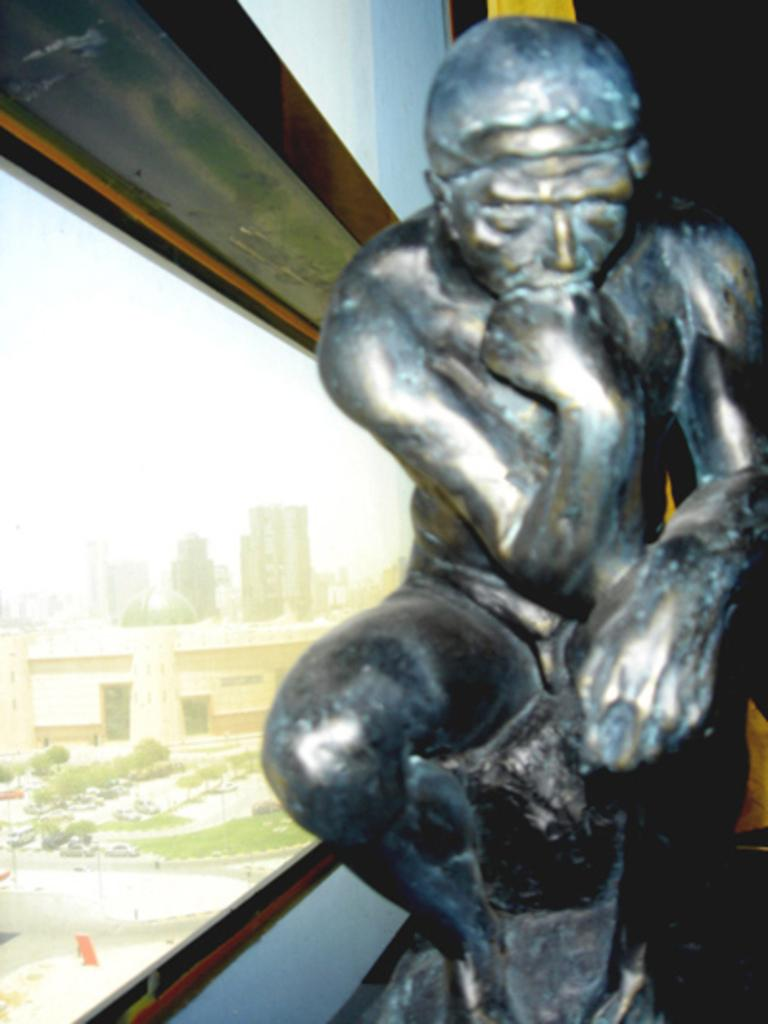Where might the image have been taken? The image might be taken inside a room. What can be seen on the right side of the image? There is a sculpture on the right side of the image. What type of window is present in the image? There is a glass window in the image. What can be seen through the glass window? Buildings and trees are visible through the glass window. How many pairs of jeans are visible in the image? There are no jeans present in the image. Are the brothers in the image playing with a knot? There are no brothers or knots present in the image. 